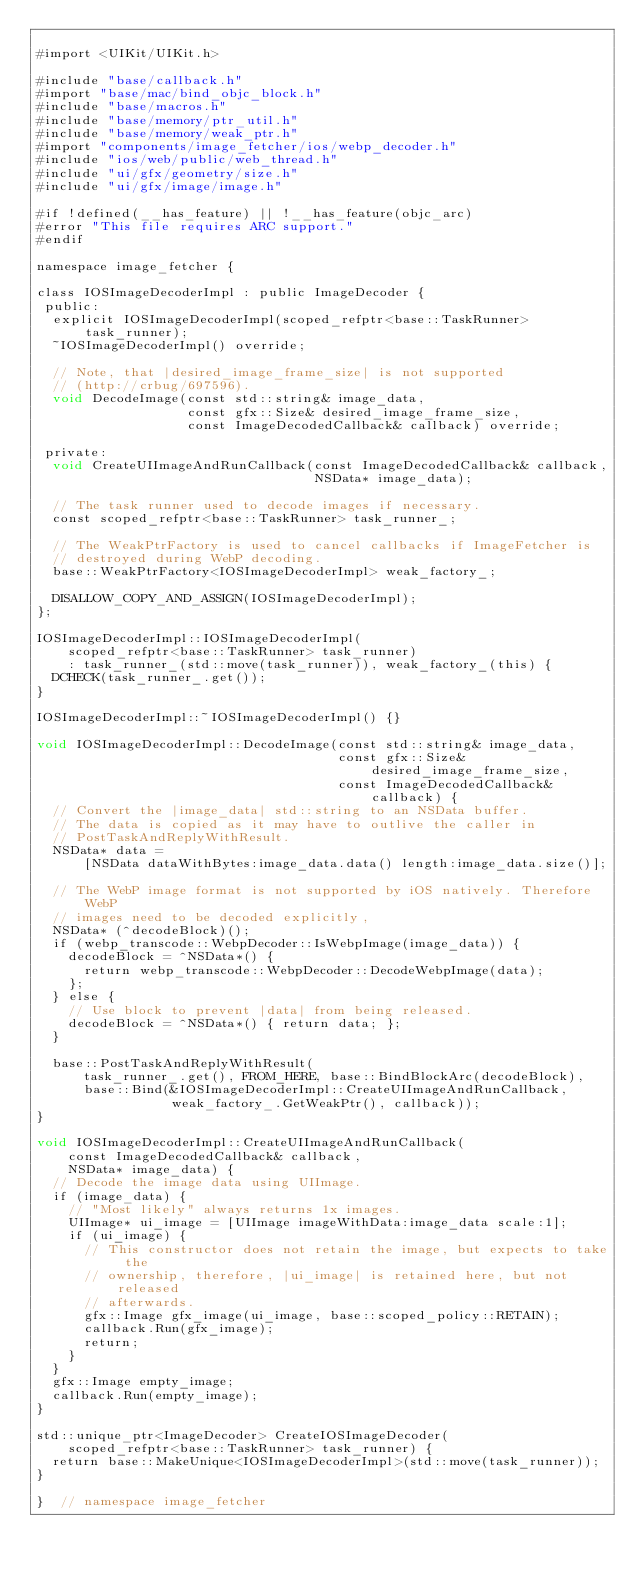<code> <loc_0><loc_0><loc_500><loc_500><_ObjectiveC_>
#import <UIKit/UIKit.h>

#include "base/callback.h"
#import "base/mac/bind_objc_block.h"
#include "base/macros.h"
#include "base/memory/ptr_util.h"
#include "base/memory/weak_ptr.h"
#import "components/image_fetcher/ios/webp_decoder.h"
#include "ios/web/public/web_thread.h"
#include "ui/gfx/geometry/size.h"
#include "ui/gfx/image/image.h"

#if !defined(__has_feature) || !__has_feature(objc_arc)
#error "This file requires ARC support."
#endif

namespace image_fetcher {

class IOSImageDecoderImpl : public ImageDecoder {
 public:
  explicit IOSImageDecoderImpl(scoped_refptr<base::TaskRunner> task_runner);
  ~IOSImageDecoderImpl() override;

  // Note, that |desired_image_frame_size| is not supported
  // (http://crbug/697596).
  void DecodeImage(const std::string& image_data,
                   const gfx::Size& desired_image_frame_size,
                   const ImageDecodedCallback& callback) override;

 private:
  void CreateUIImageAndRunCallback(const ImageDecodedCallback& callback,
                                   NSData* image_data);

  // The task runner used to decode images if necessary.
  const scoped_refptr<base::TaskRunner> task_runner_;

  // The WeakPtrFactory is used to cancel callbacks if ImageFetcher is
  // destroyed during WebP decoding.
  base::WeakPtrFactory<IOSImageDecoderImpl> weak_factory_;

  DISALLOW_COPY_AND_ASSIGN(IOSImageDecoderImpl);
};

IOSImageDecoderImpl::IOSImageDecoderImpl(
    scoped_refptr<base::TaskRunner> task_runner)
    : task_runner_(std::move(task_runner)), weak_factory_(this) {
  DCHECK(task_runner_.get());
}

IOSImageDecoderImpl::~IOSImageDecoderImpl() {}

void IOSImageDecoderImpl::DecodeImage(const std::string& image_data,
                                      const gfx::Size& desired_image_frame_size,
                                      const ImageDecodedCallback& callback) {
  // Convert the |image_data| std::string to an NSData buffer.
  // The data is copied as it may have to outlive the caller in
  // PostTaskAndReplyWithResult.
  NSData* data =
      [NSData dataWithBytes:image_data.data() length:image_data.size()];

  // The WebP image format is not supported by iOS natively. Therefore WebP
  // images need to be decoded explicitly,
  NSData* (^decodeBlock)();
  if (webp_transcode::WebpDecoder::IsWebpImage(image_data)) {
    decodeBlock = ^NSData*() {
      return webp_transcode::WebpDecoder::DecodeWebpImage(data);
    };
  } else {
    // Use block to prevent |data| from being released.
    decodeBlock = ^NSData*() { return data; };
  }

  base::PostTaskAndReplyWithResult(
      task_runner_.get(), FROM_HERE, base::BindBlockArc(decodeBlock),
      base::Bind(&IOSImageDecoderImpl::CreateUIImageAndRunCallback,
                 weak_factory_.GetWeakPtr(), callback));
}

void IOSImageDecoderImpl::CreateUIImageAndRunCallback(
    const ImageDecodedCallback& callback,
    NSData* image_data) {
  // Decode the image data using UIImage.
  if (image_data) {
    // "Most likely" always returns 1x images.
    UIImage* ui_image = [UIImage imageWithData:image_data scale:1];
    if (ui_image) {
      // This constructor does not retain the image, but expects to take the
      // ownership, therefore, |ui_image| is retained here, but not released
      // afterwards.
      gfx::Image gfx_image(ui_image, base::scoped_policy::RETAIN);
      callback.Run(gfx_image);
      return;
    }
  }
  gfx::Image empty_image;
  callback.Run(empty_image);
}

std::unique_ptr<ImageDecoder> CreateIOSImageDecoder(
    scoped_refptr<base::TaskRunner> task_runner) {
  return base::MakeUnique<IOSImageDecoderImpl>(std::move(task_runner));
}

}  // namespace image_fetcher
</code> 